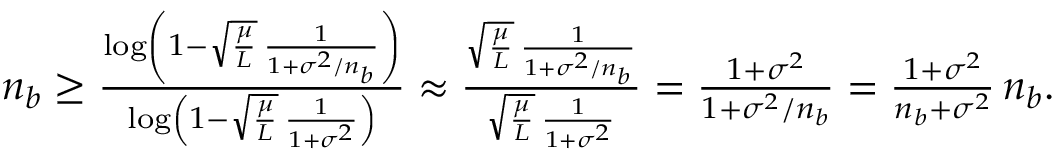<formula> <loc_0><loc_0><loc_500><loc_500>\begin{array} { r } { n _ { b } \geq \frac { \log \left ( 1 - \sqrt { } { \mu } L \, \frac { 1 } 1 + \sigma ^ { 2 } / n _ { b } } \right ) } { \log \left ( 1 - \sqrt { } { \mu } L \, \frac { 1 } 1 + \sigma ^ { 2 } } \right ) } \approx \frac { \sqrt { } { \mu } L \, \frac { 1 } { 1 + \sigma ^ { 2 } / n _ { b } } } { \sqrt { } { \mu } L \, \frac { 1 } { 1 + \sigma ^ { 2 } } } = \frac { 1 + \sigma ^ { 2 } } { 1 + \sigma ^ { 2 } / n _ { b } } = \frac { 1 + \sigma ^ { 2 } } { n _ { b } + \sigma ^ { 2 } } \, n _ { b } . } \end{array}</formula> 